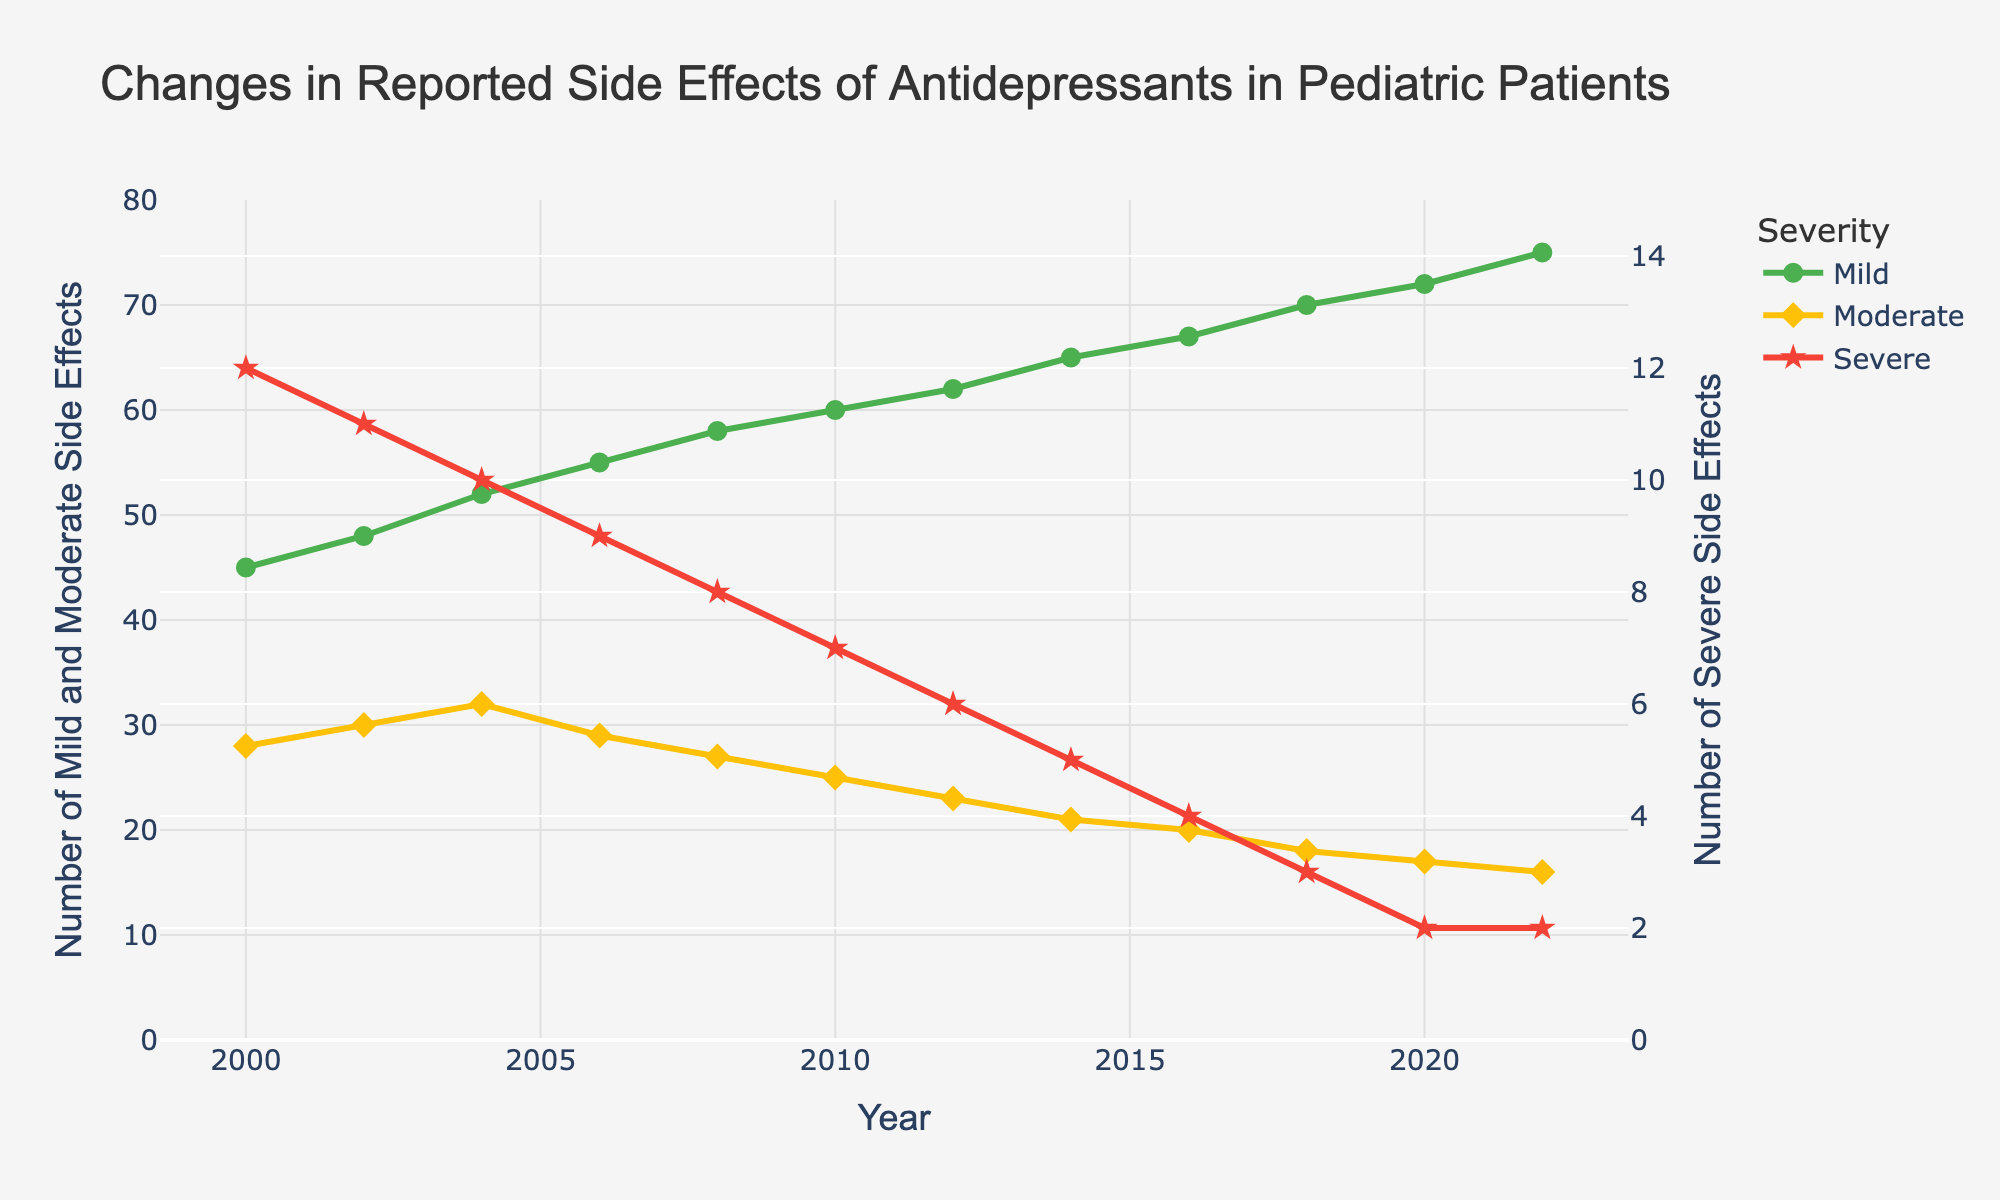What's the trend in mild side effects from 2000 to 2022? To find the trend, look at the green line representing mild side effects. From 2000 (45) to 2022 (75), the number of reported mild side effects consistently increases.
Answer: Increasing Which year has the highest number of moderate side effects? Identify the yellow line representing moderate side effects. The highest point is in 2004, where moderate side effects are reported as 32.
Answer: 2004 How do severe side effects in 2022 compare to those in 2000? Identify the red line representing severe side effects. In 2000, severe side effects are 12, and in 2022, they are 2. Comparing the values, severe side effects have decreased.
Answer: Decreased What is the difference in the number of mild side effects between 2000 and 2022? Look at the data points for mild side effects: 2000 has 45 and 2022 has 75. The difference is 75 - 45.
Answer: 30 What is the average number of moderate side effects between 2000 and 2022? Sum the number of moderate side effects for each year and divide by the number of years: (28 + 30 + 32 + 29 + 27 + 25 + 23 + 21 + 20 + 18 + 17 + 16) / 12.
Answer: 24.25 Which type of side effect has shown the most significant decrease over the years? Compare the trends of all three lines. The red line (severe side effects) shows the steepest decline from 12 in 2000 to 2 in 2022.
Answer: Severe side effects In which year was the difference between mild and severe side effects the greatest? Estimate the differences for each year and find the maximum: the highest difference is in 2022 with mild at 75 and severe at 2, resulting in a difference of 73.
Answer: 2022 How many years have seen a decrease in moderate side effects? Count the years where the yellow line (moderate side effects) decreases from the previous year. 2006, 2008, 2010, 2012, 2014, 2016, 2018, 2020, 2022 show such a decrease.
Answer: 9 What color is the line representing severe side effects? Identify the visual representation for severe side effects; the line color is red.
Answer: Red By how much did severe side effects decrease from 2000 to 2020? Compare the severe side effects for 2000 (12) and 2020 (2), and calculate the difference: 12 - 2.
Answer: 10 